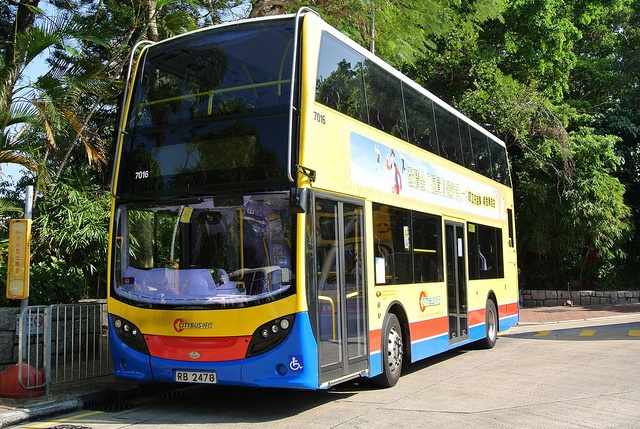Describe the objects in this image and their specific colors. I can see bus in lightblue, black, beige, gray, and navy tones in this image. 